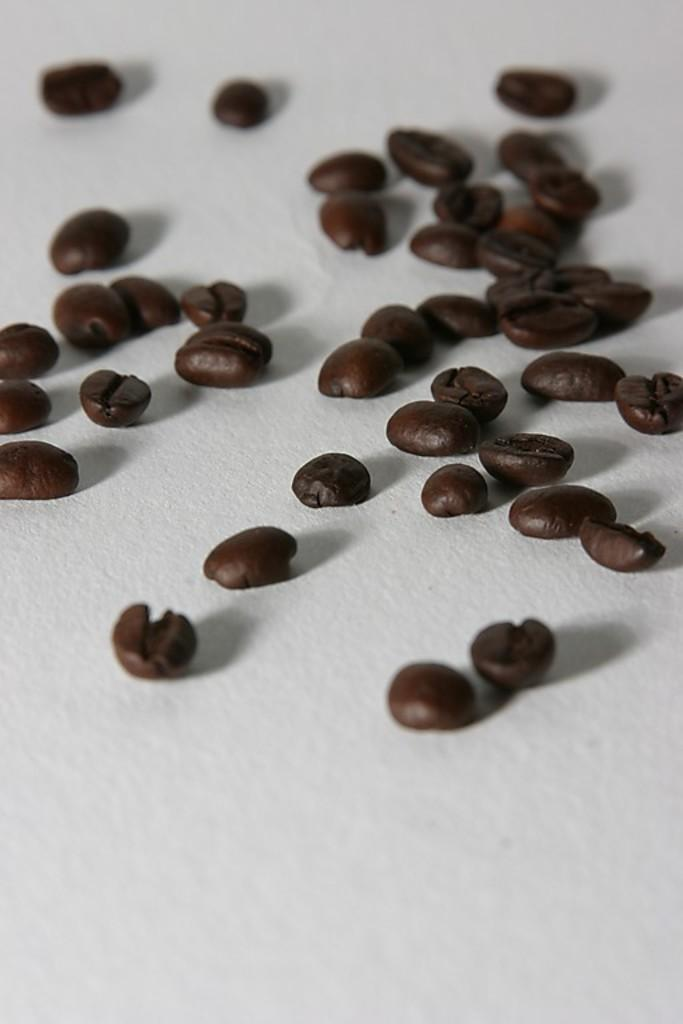What is the main subject of the image? The main subject of the image is coffee beans. Where are the coffee beans placed in the image? The coffee beans are placed on a surface in the image. How are the coffee beans arranged in the image? The coffee beans are located in the center of the image. What is the opinion of the coffee beans about the dock in the image? There is no dock present in the image, and coffee beans do not have opinions. 